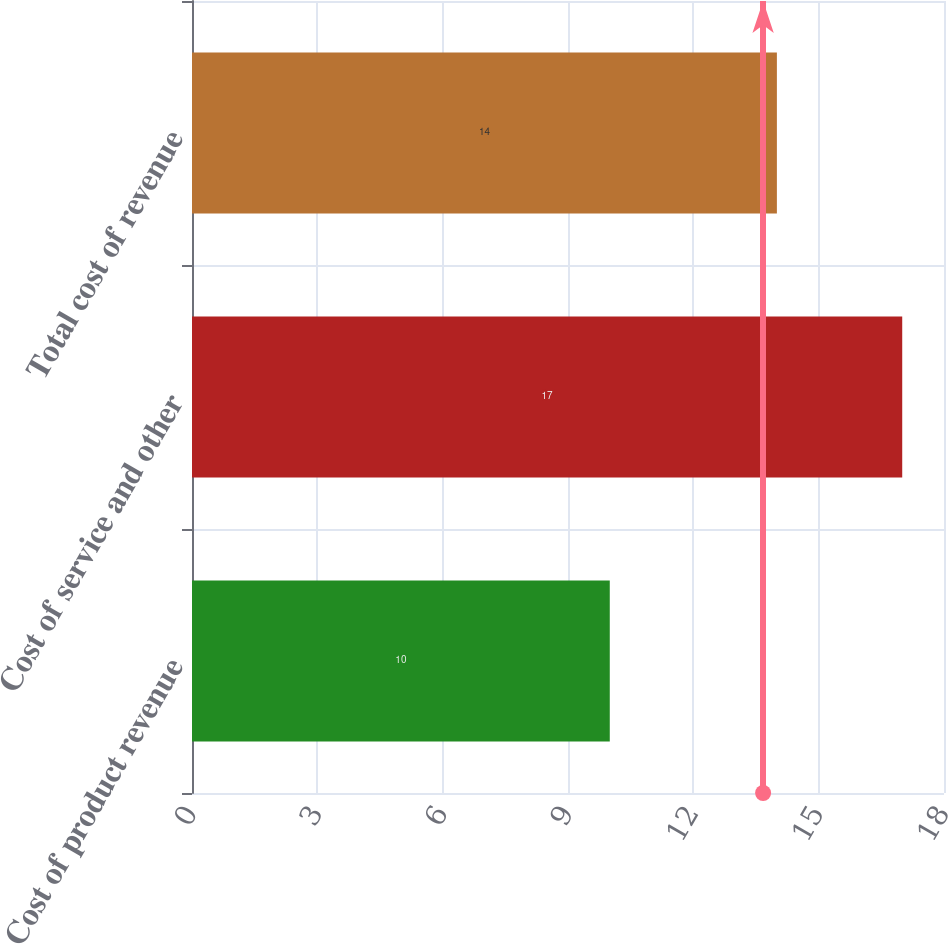Convert chart. <chart><loc_0><loc_0><loc_500><loc_500><bar_chart><fcel>Cost of product revenue<fcel>Cost of service and other<fcel>Total cost of revenue<nl><fcel>10<fcel>17<fcel>14<nl></chart> 